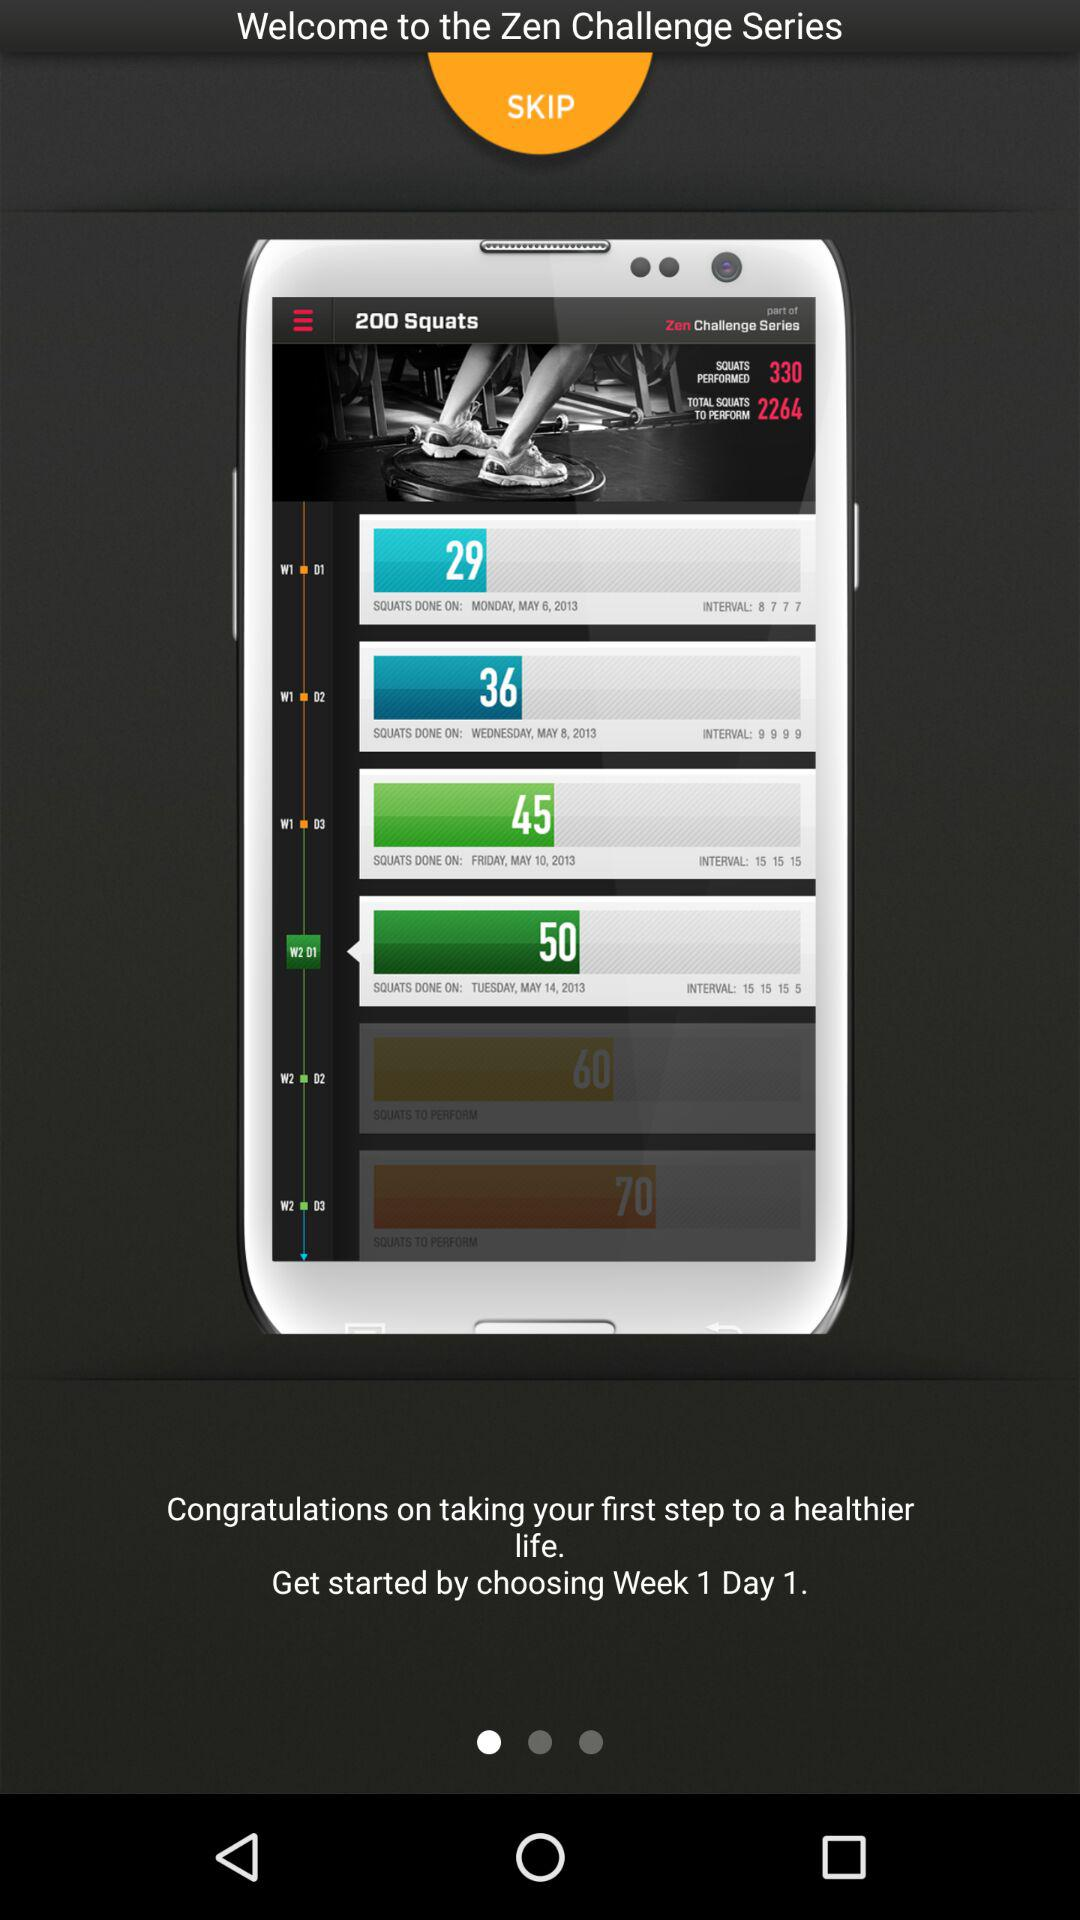How to get started? You can get started by choosing Week 1 Day 1. 